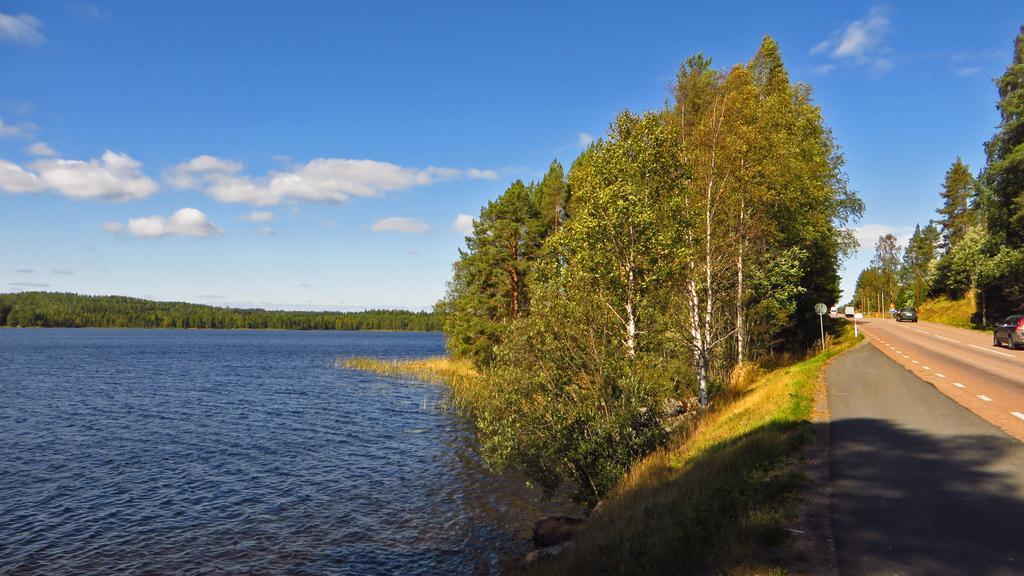In one or two sentences, can you explain what this image depicts? In this image we can see sky with clouds, trees, water, grass, sign boards and motor vehicles on the road. 